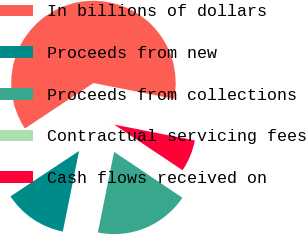Convert chart to OTSL. <chart><loc_0><loc_0><loc_500><loc_500><pie_chart><fcel>In billions of dollars<fcel>Proceeds from new<fcel>Proceeds from collections<fcel>Contractual servicing fees<fcel>Cash flows received on<nl><fcel>62.41%<fcel>12.52%<fcel>18.75%<fcel>0.04%<fcel>6.28%<nl></chart> 